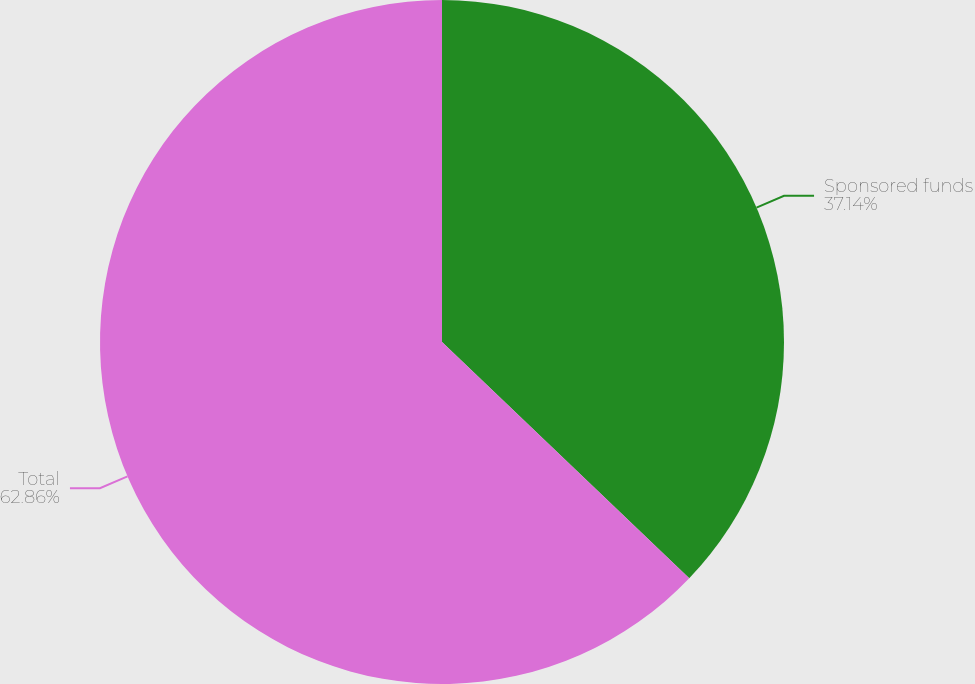Convert chart to OTSL. <chart><loc_0><loc_0><loc_500><loc_500><pie_chart><fcel>Sponsored funds<fcel>Total<nl><fcel>37.14%<fcel>62.86%<nl></chart> 